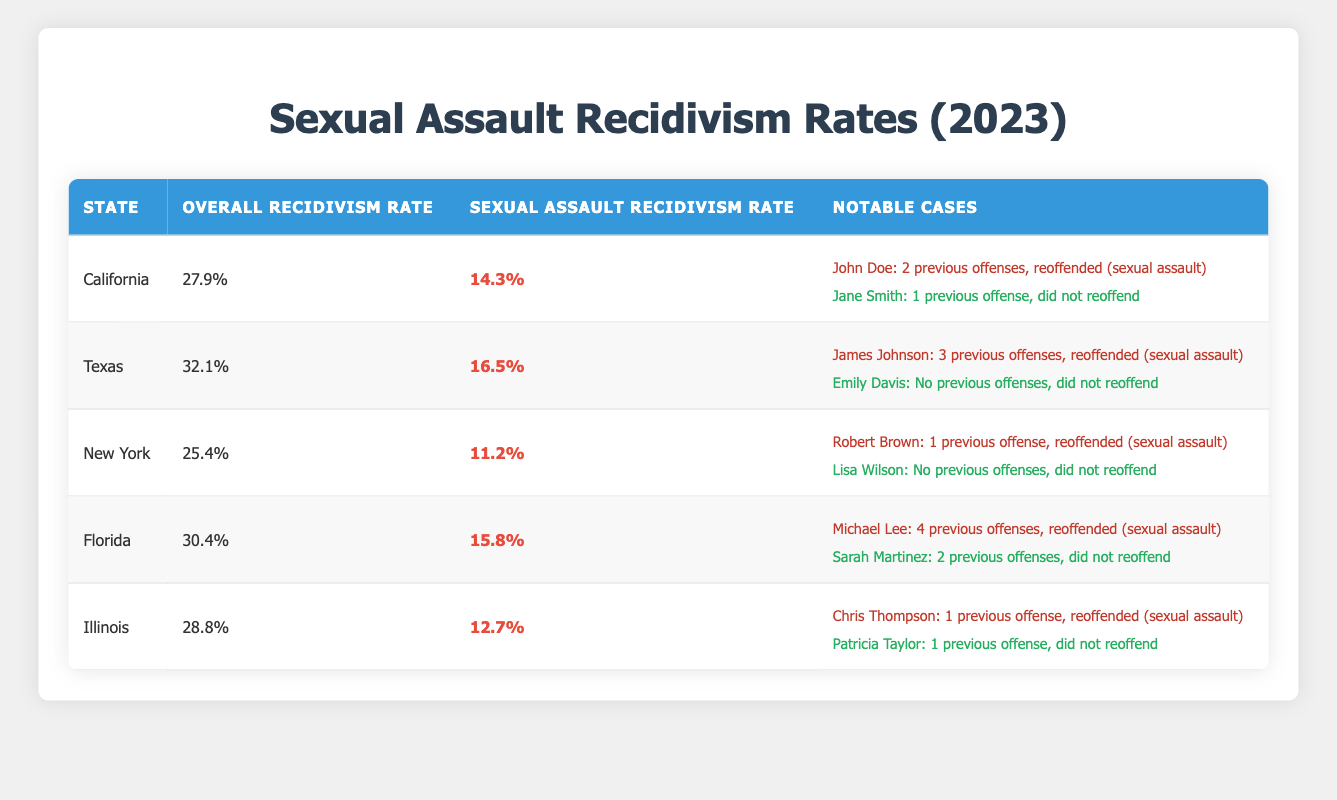What is the sexual assault recidivism rate in Texas? The table shows that the sexual assault recidivism rate in Texas for 2023 is highlighted as 16.5%.
Answer: 16.5% Which state has the highest overall recidivism rate? By reviewing the overall recidivism rates, Texas has the highest overall rate at 32.1%.
Answer: Texas How many notable cases of reoffending are reported in California? The table lists notable cases for California and mentions one case of reoffending (John Doe) under notable cases. Therefore, there is 1 reoffender reported.
Answer: 1 What is the difference between the sexual assault recidivism rates in California and Florida? The sexual assault recidivism rate in California is 14.3% and in Florida it is 15.8%. The difference is calculated as 15.8% - 14.3% = 1.5%.
Answer: 1.5% Which offender in New York has reoffended and what type of offense is it? The notable cases for New York show that Robert Brown reoffended with a type of offense listed as sexual assault.
Answer: Robert Brown, sexual assault What percentage of offenders reoffended in Illinois compared to New York? In Illinois, the percentage of sexual assault recidivism is 12.7%, while in New York it is 11.2%. Illinois has a higher rate than New York, calculated as 12.7% - 11.2% = 1.5%.
Answer: Illinois has a higher rate by 1.5% How many previous offenses did Michael Lee have before reoffending? The table indicates that Michael Lee had 4 previous offenses before reoffending for sexual assault.
Answer: 4 Is the sexual assault recidivism rate in Florida higher than in California? The table shows Florida's sexual assault recidivism rate at 15.8% and California's at 14.3%. Since 15.8% is greater than 14.3%, the answer is yes.
Answer: Yes What is the average sexual assault recidivism rate across the five states listed? The rates are: California 14.3%, Texas 16.5%, New York 11.2%, Florida 15.8%, and Illinois 12.7%. Summing these (14.3 + 16.5 + 11.2 + 15.8 + 12.7) equals 70.5. Dividing by 5 gives an average of 14.1%.
Answer: 14.1% Which offender from Texas did not reoffend and what was their previous offense count? The table states that Emily Davis from Texas did not reoffend and had no previous offenses indicated.
Answer: Emily Davis, 0 previous offenses In which state did the offender with the highest number of previous offenses reoffend? The table shows that Michael Lee from Florida had the highest number of previous offenses (4) and he reoffended for sexual assault.
Answer: Florida 